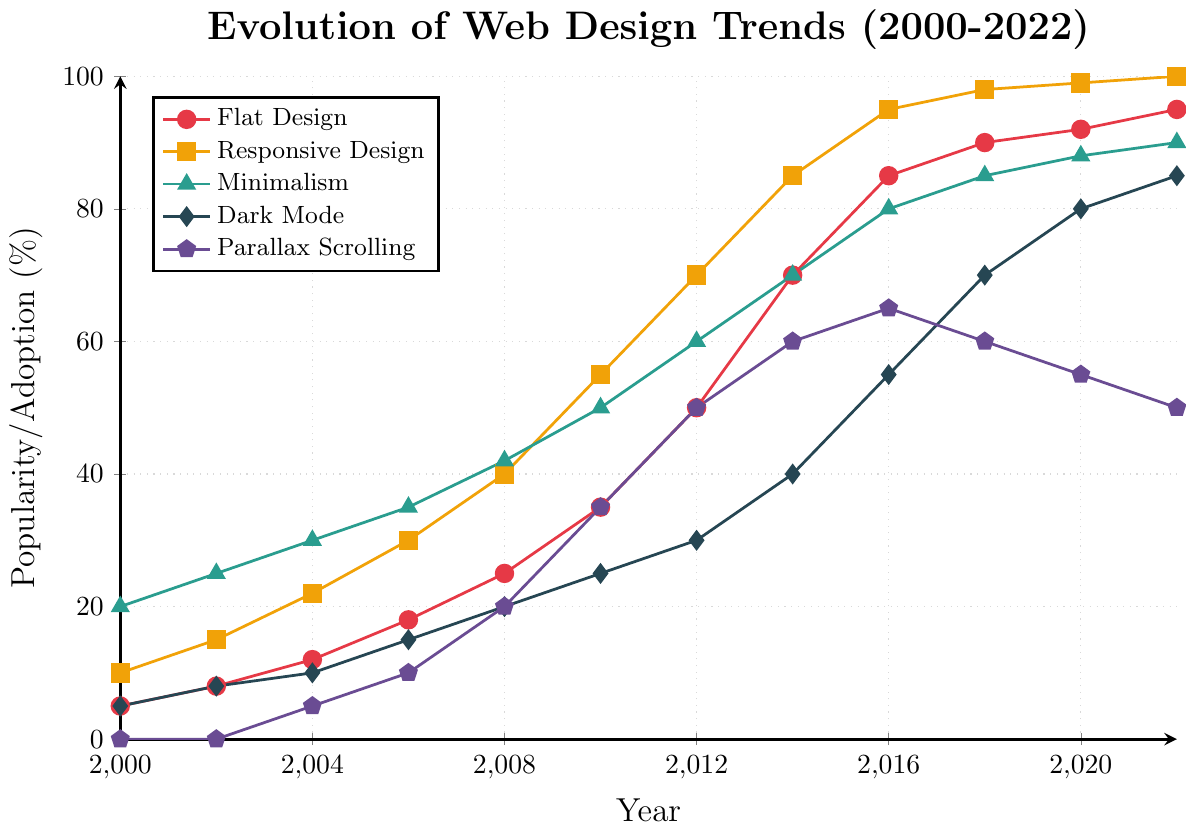Which design trend saw the most significant increase in popularity between 2000 and 2022? From 2000 to 2022, all trends saw increases, so we need to calculate the changes: Flat Design (95-5=90), Responsive Design (100-10=90), Minimalism (90-20=70), Dark Mode (85-5=80), Parallax Scrolling (50-0=50). Comparing these, Flat Design and Responsive Design both saw the highest increase of 90%.
Answer: Flat Design and Responsive Design Between 2012 and 2020, which trend experienced the highest growth rate? First, calculate the growth rates between 2012 and 2020: Flat Design (92-50=42), Responsive Design (99-70=29), Minimalism (88-60=28), Dark Mode (80-30=50), Parallax Scrolling (55-50=5). Among these, Dark Mode saw the most significant growth of 50%.
Answer: Dark Mode In what year did Flat Design surpass Parallax Scrolling in popularity? To determine this, check the plot for when the Flat Design trend line is above the Parallax Scrolling trend line for the first time. This occurred in 2006 when Flat Design was at 18% and Parallax Scrolling was at 10%.
Answer: 2006 What is the average popularity of Minimalism over the 22-year period? Sum the popularity percentages of Minimalism (20+25+30+35+42+50+60+70+80+85+88+90) which equals 675, then divide by the number of years (12). Average = 675/12.
Answer: 56.25% How does the popularity of Dark Mode in 2022 compare to that of Minimalism in the same year? In 2022, Dark Mode was at 85% and Minimalism was at 90%. Comparing these, Minimalism is higher.
Answer: Minimalism is higher Which trend reached a popularity of above 50% first? From the plot, identify the earliest year a trend crossed 50%. Flat Design achieved 50% in 2012, Responsive Design in 2010, Minimalism in 2010, Dark Mode in 2016, and Parallax Scrolling in 2012. Responsive Design and Minimalism both reached above 50% first in 2010.
Answer: Responsive Design and Minimalism 